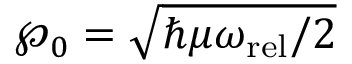<formula> <loc_0><loc_0><loc_500><loc_500>\wp _ { 0 } = \sqrt { \hbar { \mu } \omega _ { r e l } / 2 }</formula> 